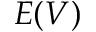Convert formula to latex. <formula><loc_0><loc_0><loc_500><loc_500>E ( V )</formula> 